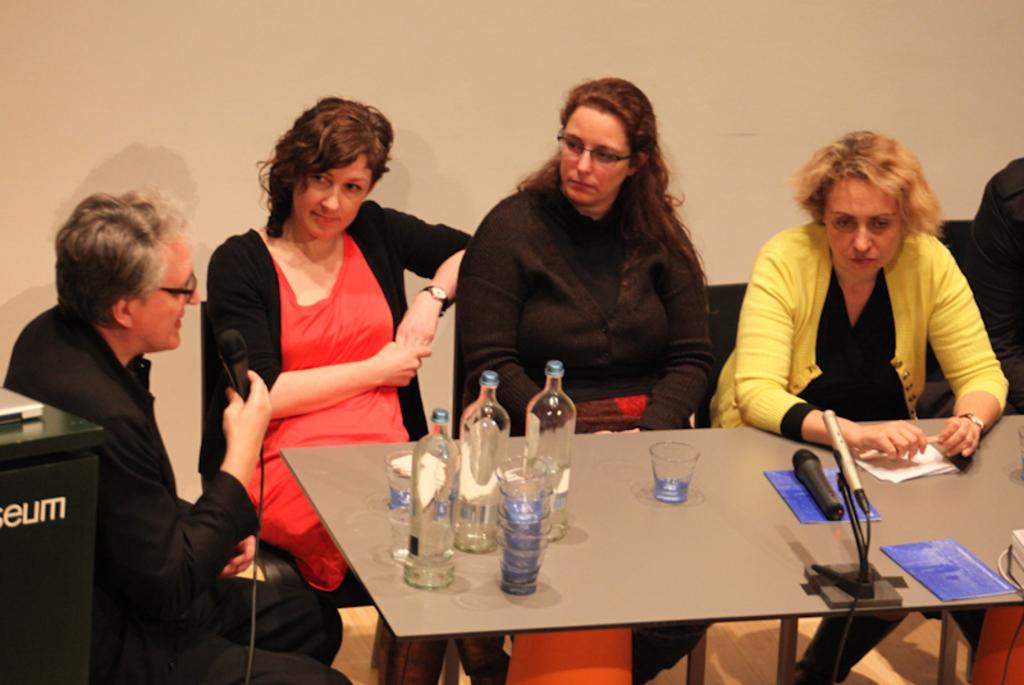What are the people in the image doing? The people in the image are sitting on chairs. What is the man holding in his hand? The man is holding a microphone in his hand. What can be seen on the table in the image? There is a water bottle and glasses on the table. What might the people be using the glasses for? The glasses might be used for drinking water from the water bottle. What type of chain can be seen hanging from the ceiling in the image? There is no chain visible in the image. Is there a cemetery present in the image? No, there is no cemetery present in the image. 